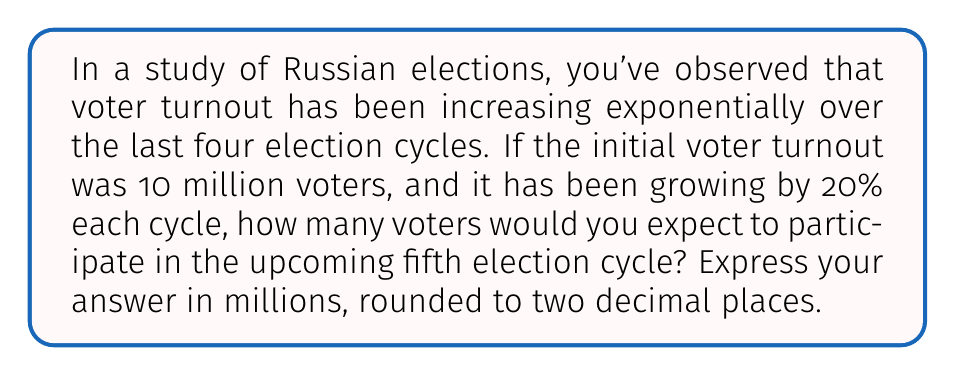Can you answer this question? To solve this problem, we'll use the exponential growth formula:

$$A = P(1 + r)^n$$

Where:
$A$ = Final amount
$P$ = Initial amount (principal)
$r$ = Growth rate (as a decimal)
$n$ = Number of periods

Given:
$P = 10$ million voters
$r = 20\% = 0.20$
$n = 4$ cycles

Let's calculate step-by-step:

1) Plug the values into the formula:
   $$A = 10(1 + 0.20)^4$$

2) Simplify the parentheses:
   $$A = 10(1.20)^4$$

3) Calculate the exponent:
   $$A = 10 \times 2.0736$$

4) Multiply:
   $$A = 20.736$$

5) Round to two decimal places:
   $$A \approx 20.74$$

Therefore, we expect approximately 20.74 million voters to participate in the fifth election cycle.
Answer: 20.74 million voters 